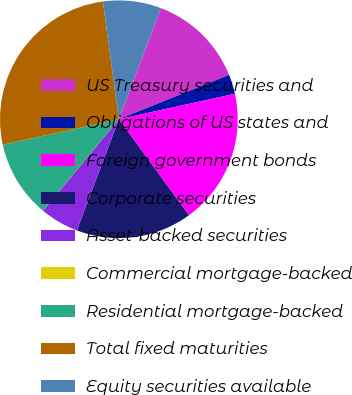<chart> <loc_0><loc_0><loc_500><loc_500><pie_chart><fcel>US Treasury securities and<fcel>Obligations of US states and<fcel>Foreign government bonds<fcel>Corporate securities<fcel>Asset-backed securities<fcel>Commercial mortgage-backed<fcel>Residential mortgage-backed<fcel>Total fixed maturities<fcel>Equity securities available<nl><fcel>13.15%<fcel>2.65%<fcel>18.41%<fcel>15.78%<fcel>5.27%<fcel>0.02%<fcel>10.53%<fcel>26.29%<fcel>7.9%<nl></chart> 